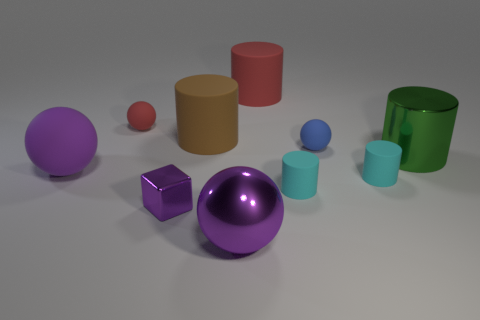Subtract 1 spheres. How many spheres are left? 3 Subtract all red cylinders. How many cylinders are left? 4 Subtract all green cylinders. How many cylinders are left? 4 Subtract all gray cylinders. Subtract all red blocks. How many cylinders are left? 5 Subtract all blocks. How many objects are left? 9 Add 8 large shiny spheres. How many large shiny spheres are left? 9 Add 7 large rubber cylinders. How many large rubber cylinders exist? 9 Subtract 0 green blocks. How many objects are left? 10 Subtract all small red shiny cylinders. Subtract all big red matte cylinders. How many objects are left? 9 